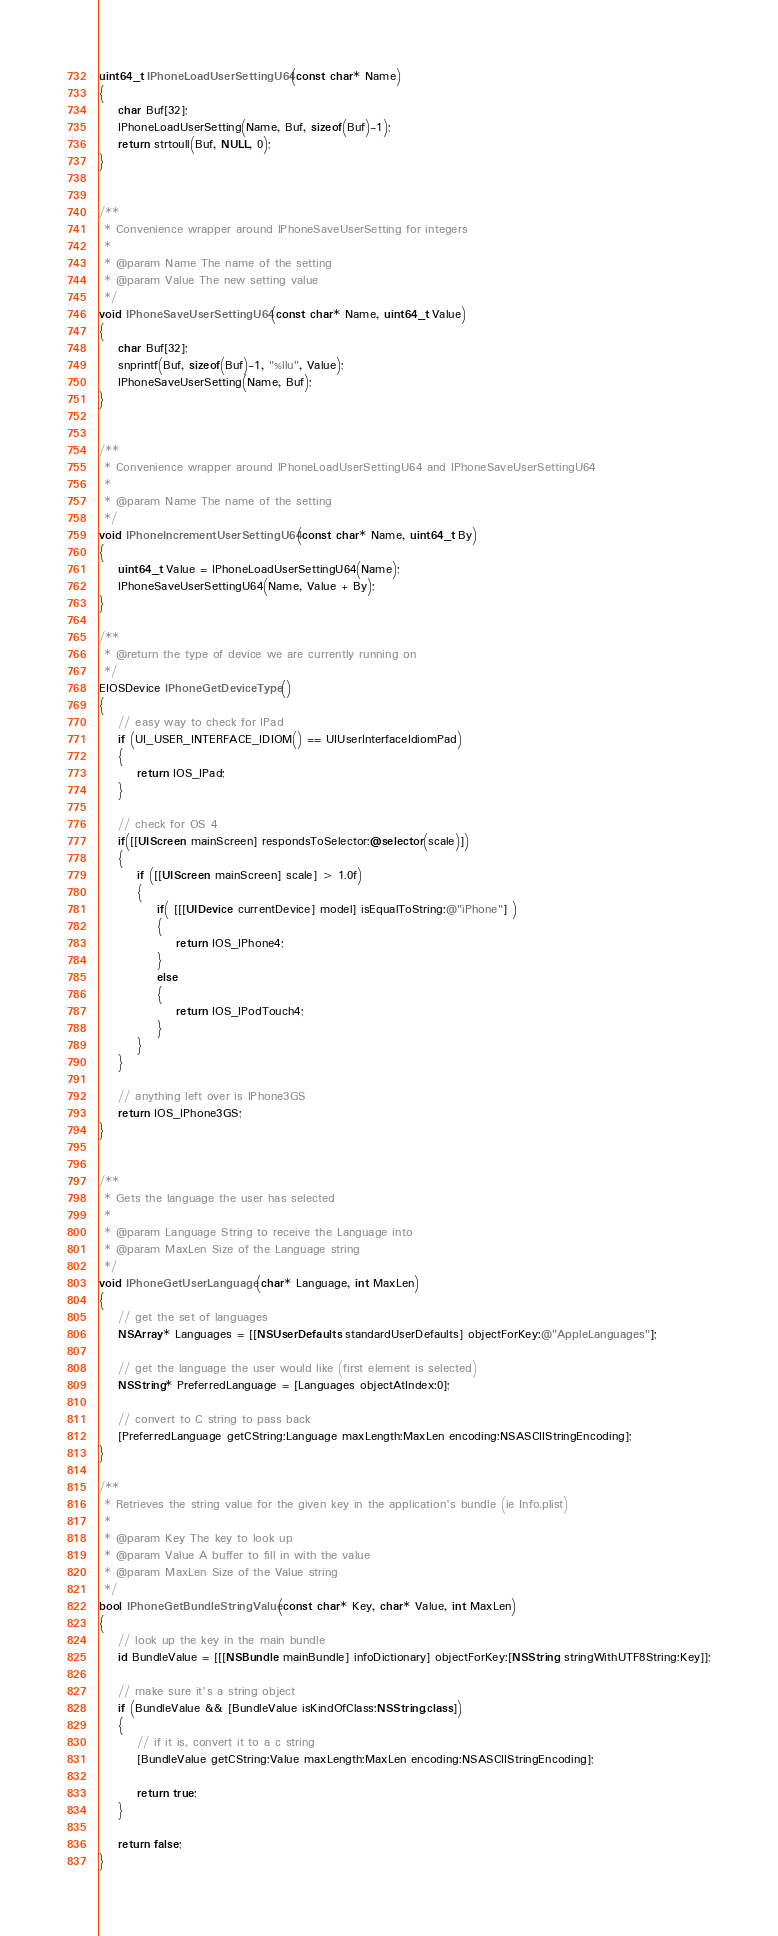<code> <loc_0><loc_0><loc_500><loc_500><_ObjectiveC_>uint64_t IPhoneLoadUserSettingU64(const char* Name)
{
	char Buf[32];
	IPhoneLoadUserSetting(Name, Buf, sizeof(Buf)-1); 
	return strtoull(Buf, NULL, 0);
}


/**
 * Convenience wrapper around IPhoneSaveUserSetting for integers
 * 
 * @param Name The name of the setting
 * @param Value The new setting value
 */
void IPhoneSaveUserSettingU64(const char* Name, uint64_t Value)
{
	char Buf[32];
	snprintf(Buf, sizeof(Buf)-1, "%llu", Value);
	IPhoneSaveUserSetting(Name, Buf); 
}


/**
 * Convenience wrapper around IPhoneLoadUserSettingU64 and IPhoneSaveUserSettingU64
 *
 * @param Name The name of the setting
 */
void IPhoneIncrementUserSettingU64(const char* Name, uint64_t By)
{
	uint64_t Value = IPhoneLoadUserSettingU64(Name);
	IPhoneSaveUserSettingU64(Name, Value + By);
}

/**
 * @return the type of device we are currently running on
 */
EIOSDevice IPhoneGetDeviceType()
{
	// easy way to check for IPad
	if (UI_USER_INTERFACE_IDIOM() == UIUserInterfaceIdiomPad)
	{
		return IOS_IPad;
	}

	// check for OS 4
	if([[UIScreen mainScreen] respondsToSelector:@selector(scale)]) 
	{
		if ([[UIScreen mainScreen] scale] > 1.0f)
		{
			if( [[[UIDevice currentDevice] model] isEqualToString:@"iPhone"] )
			{
				return IOS_IPhone4;
			}
			else
			{
				return IOS_IPodTouch4;
			}
		}
	}

	// anything left over is IPhone3GS
	return IOS_IPhone3GS;
}


/**
 * Gets the language the user has selected
 *
 * @param Language String to receive the Language into
 * @param MaxLen Size of the Language string
 */
void IPhoneGetUserLanguage(char* Language, int MaxLen)
{
	// get the set of languages
	NSArray* Languages = [[NSUserDefaults standardUserDefaults] objectForKey:@"AppleLanguages"];

	// get the language the user would like (first element is selected)
	NSString* PreferredLanguage = [Languages objectAtIndex:0];

	// convert to C string to pass back
	[PreferredLanguage getCString:Language maxLength:MaxLen encoding:NSASCIIStringEncoding];
}

/**
 * Retrieves the string value for the given key in the application's bundle (ie Info.plist)
 *
 * @param Key The key to look up
 * @param Value A buffer to fill in with the value
 * @param MaxLen Size of the Value string
 */
bool IPhoneGetBundleStringValue(const char* Key, char* Value, int MaxLen)
{
	// look up the key in the main bundle
	id BundleValue = [[[NSBundle mainBundle] infoDictionary] objectForKey:[NSString stringWithUTF8String:Key]];

	// make sure it's a string object
	if (BundleValue && [BundleValue isKindOfClass:NSString.class])
	{
		// if it is, convert it to a c string
		[BundleValue getCString:Value maxLength:MaxLen encoding:NSASCIIStringEncoding];
		
		return true;
	}

	return false;
}</code> 